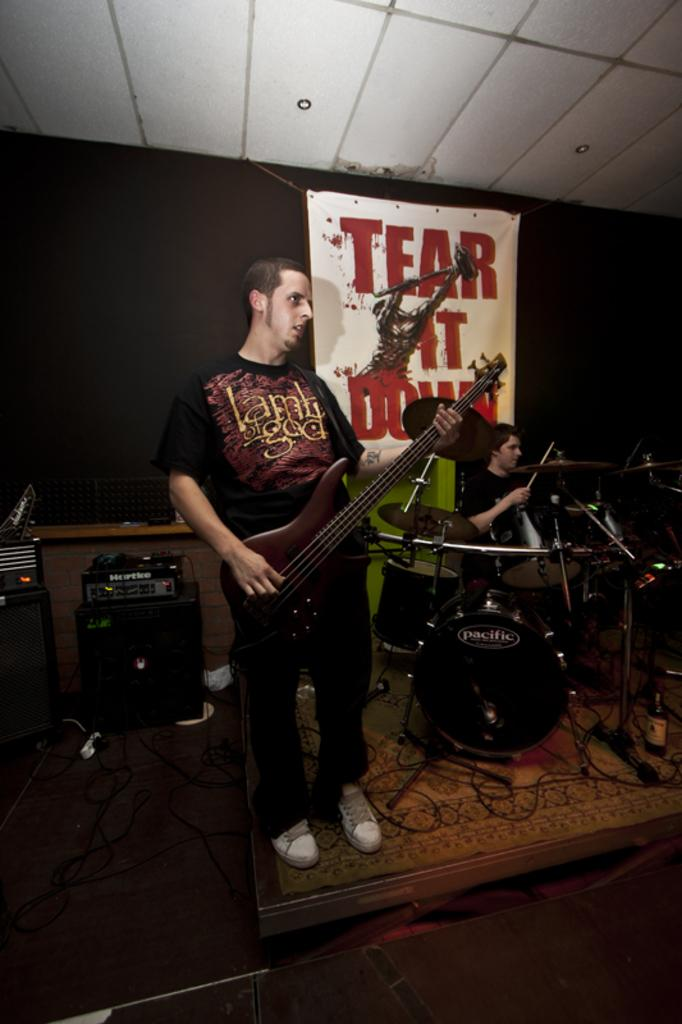What is the man in the image doing with the guitar? The man is playing the guitar in the image. Can you describe the other person in the image? There is a man sitting on a chair in the image, and he is playing drums. What message is conveyed by the banner in the image? The banner in the image has the text "tear it down". What type of finger food is present on the guitar in the image? There are no finger foods present on the guitar in the image. Can you describe the pickle that is being used to play the drums in the image? There are no pickles present in the image, and the drums are being played with drumsticks or hands. 